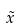<formula> <loc_0><loc_0><loc_500><loc_500>\tilde { x }</formula> 